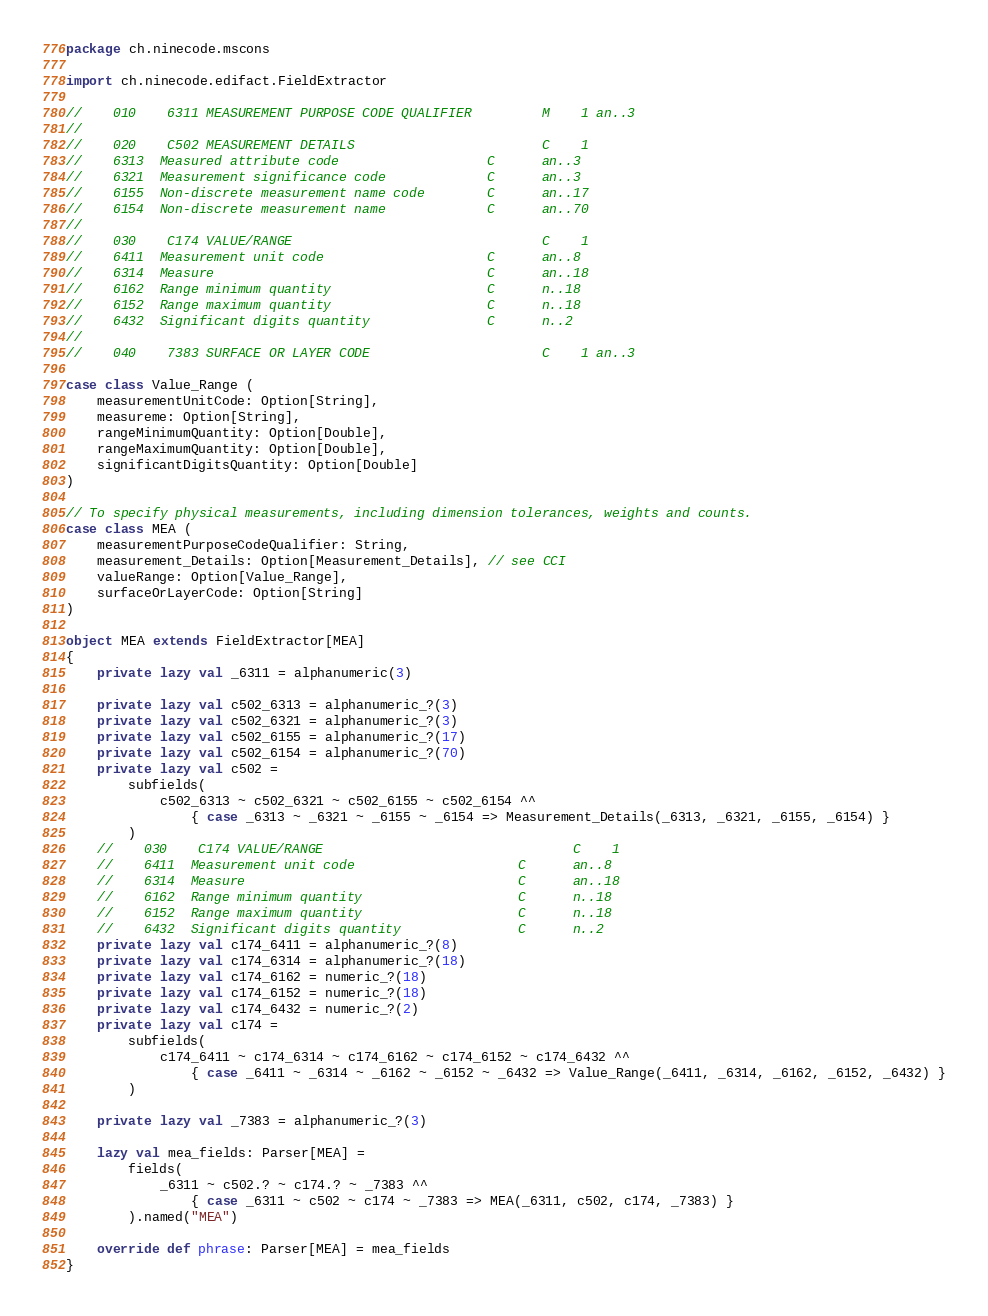Convert code to text. <code><loc_0><loc_0><loc_500><loc_500><_Scala_>package ch.ninecode.mscons

import ch.ninecode.edifact.FieldExtractor

//    010    6311 MEASUREMENT PURPOSE CODE QUALIFIER         M    1 an..3
//
//    020    C502 MEASUREMENT DETAILS                        C    1
//    6313  Measured attribute code                   C      an..3
//    6321  Measurement significance code             C      an..3
//    6155  Non-discrete measurement name code        C      an..17
//    6154  Non-discrete measurement name             C      an..70
//
//    030    C174 VALUE/RANGE                                C    1
//    6411  Measurement unit code                     C      an..8
//    6314  Measure                                   C      an..18
//    6162  Range minimum quantity                    C      n..18
//    6152  Range maximum quantity                    C      n..18
//    6432  Significant digits quantity               C      n..2
//
//    040    7383 SURFACE OR LAYER CODE                      C    1 an..3

case class Value_Range (
    measurementUnitCode: Option[String],
    measureme: Option[String],
    rangeMinimumQuantity: Option[Double],
    rangeMaximumQuantity: Option[Double],
    significantDigitsQuantity: Option[Double]
)

// To specify physical measurements, including dimension tolerances, weights and counts.
case class MEA (
    measurementPurposeCodeQualifier: String,
    measurement_Details: Option[Measurement_Details], // see CCI
    valueRange: Option[Value_Range],
    surfaceOrLayerCode: Option[String]
)

object MEA extends FieldExtractor[MEA]
{
    private lazy val _6311 = alphanumeric(3)

    private lazy val c502_6313 = alphanumeric_?(3)
    private lazy val c502_6321 = alphanumeric_?(3)
    private lazy val c502_6155 = alphanumeric_?(17)
    private lazy val c502_6154 = alphanumeric_?(70)
    private lazy val c502 =
        subfields(
            c502_6313 ~ c502_6321 ~ c502_6155 ~ c502_6154 ^^
                { case _6313 ~ _6321 ~ _6155 ~ _6154 => Measurement_Details(_6313, _6321, _6155, _6154) }
        )
    //    030    C174 VALUE/RANGE                                C    1
    //    6411  Measurement unit code                     C      an..8
    //    6314  Measure                                   C      an..18
    //    6162  Range minimum quantity                    C      n..18
    //    6152  Range maximum quantity                    C      n..18
    //    6432  Significant digits quantity               C      n..2
    private lazy val c174_6411 = alphanumeric_?(8)
    private lazy val c174_6314 = alphanumeric_?(18)
    private lazy val c174_6162 = numeric_?(18)
    private lazy val c174_6152 = numeric_?(18)
    private lazy val c174_6432 = numeric_?(2)
    private lazy val c174 =
        subfields(
            c174_6411 ~ c174_6314 ~ c174_6162 ~ c174_6152 ~ c174_6432 ^^
                { case _6411 ~ _6314 ~ _6162 ~ _6152 ~ _6432 => Value_Range(_6411, _6314, _6162, _6152, _6432) }
        )

    private lazy val _7383 = alphanumeric_?(3)

    lazy val mea_fields: Parser[MEA] =
        fields(
            _6311 ~ c502.? ~ c174.? ~ _7383 ^^
                { case _6311 ~ c502 ~ c174 ~ _7383 => MEA(_6311, c502, c174, _7383) }
        ).named("MEA")

    override def phrase: Parser[MEA] = mea_fields
}</code> 